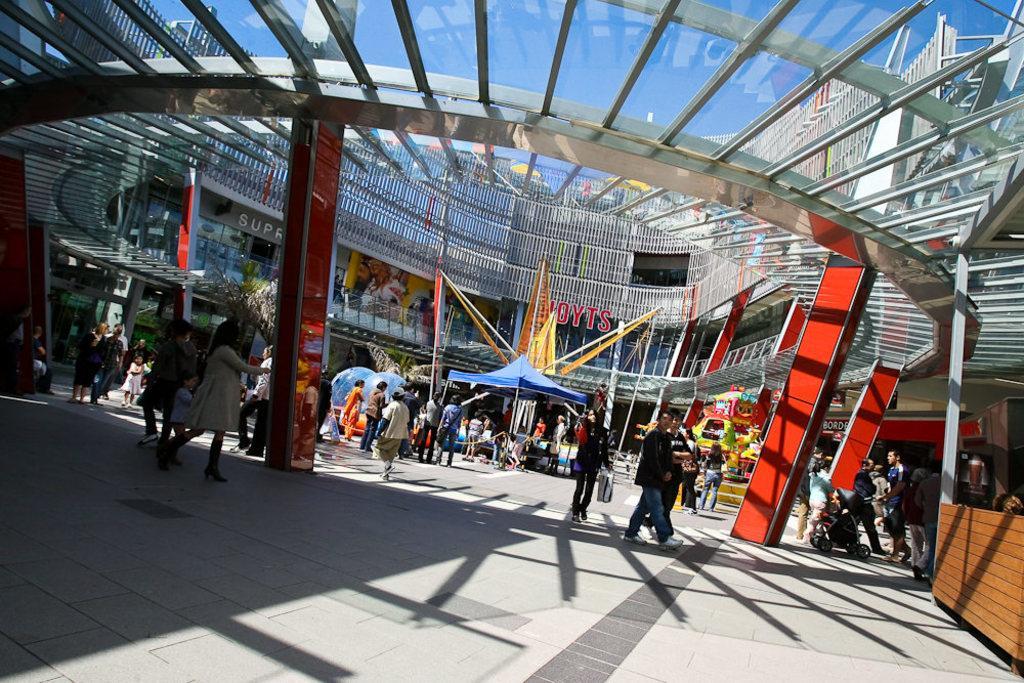Please provide a concise description of this image. In this picture, we see people walking. In the middle of the picture, we see people sitting under the blue tent and beside that, there are water balls. Beside that, we see many games. In the background, we see a big building. This picture might be clicked in the mall. In the right bottom of the picture, we see a table and at the top of the picture, we see the sky. 